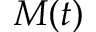<formula> <loc_0><loc_0><loc_500><loc_500>M ( t )</formula> 